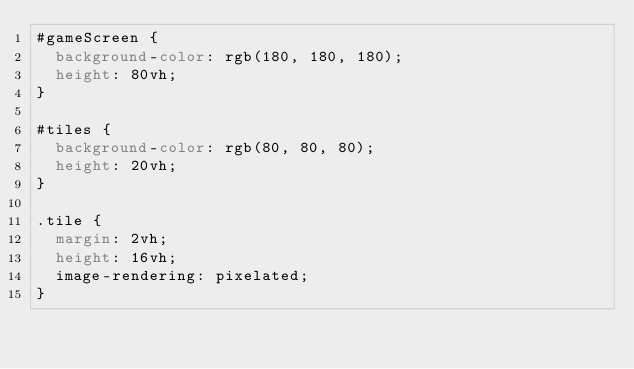Convert code to text. <code><loc_0><loc_0><loc_500><loc_500><_CSS_>#gameScreen {
  background-color: rgb(180, 180, 180);
  height: 80vh;
}

#tiles {
  background-color: rgb(80, 80, 80);
  height: 20vh;
}

.tile {
  margin: 2vh;
  height: 16vh;
  image-rendering: pixelated;
}
</code> 